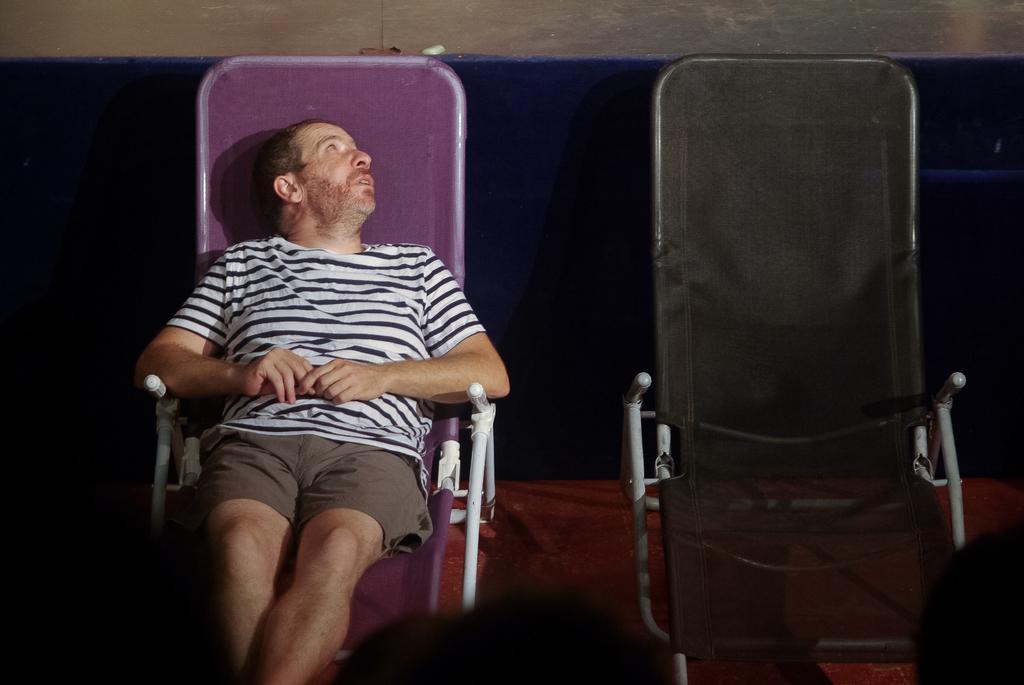How would you summarize this image in a sentence or two? Here we can see a man who is sitting on the chair. These are the chairs. This is floor. On the background there is a wall. 